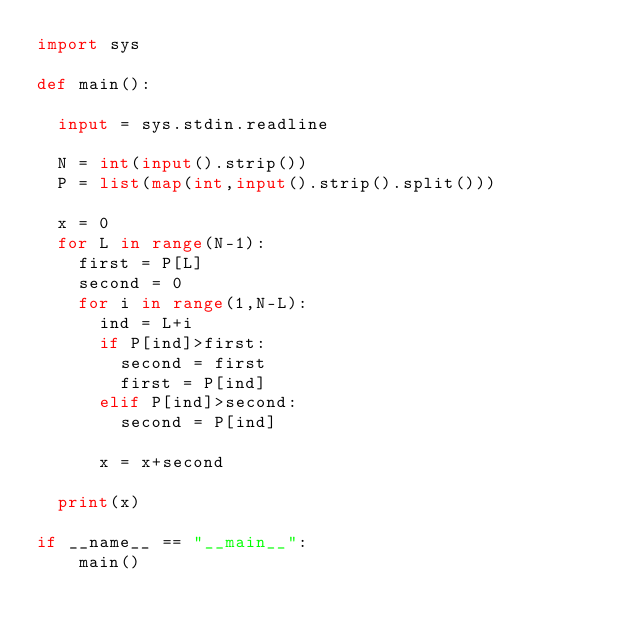<code> <loc_0><loc_0><loc_500><loc_500><_Python_>import sys

def main():

	input = sys.stdin.readline

	N = int(input().strip())
	P = list(map(int,input().strip().split()))

	x = 0
	for L in range(N-1):
		first = P[L]
		second = 0
		for i in range(1,N-L):
			ind = L+i
			if P[ind]>first:
				second = first
				first = P[ind]
			elif P[ind]>second:
				second = P[ind]

			x = x+second

	print(x)

if __name__ == "__main__":
    main()
</code> 